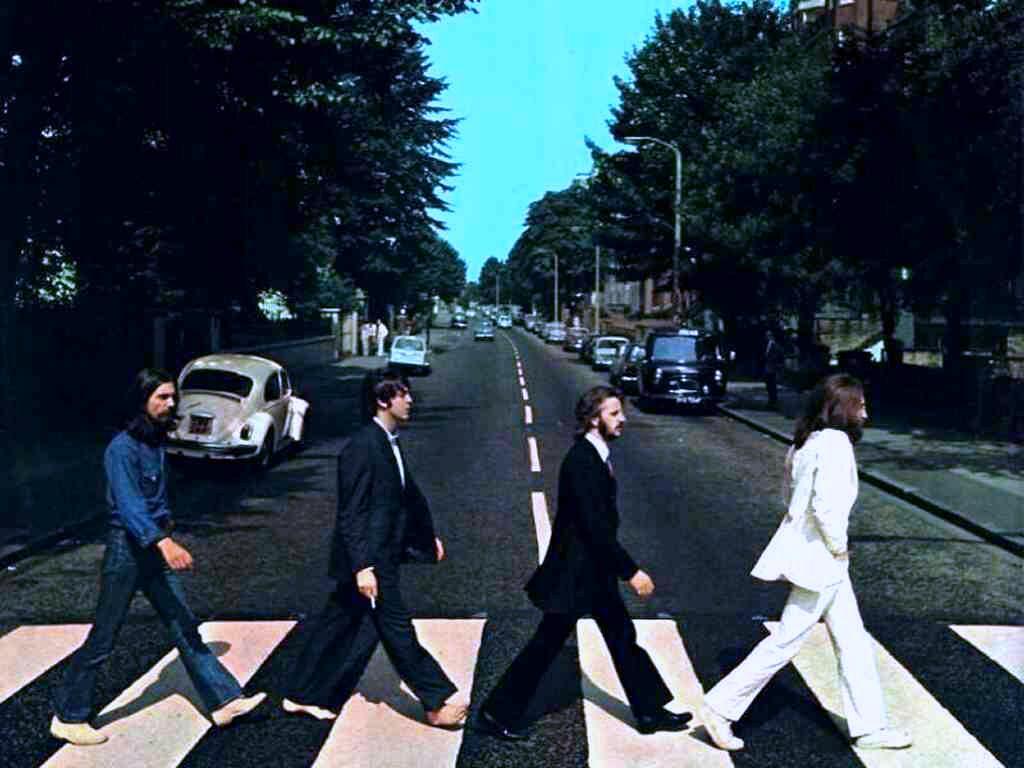Please provide a concise description of this image. This picture might be taken on the wide road. In this image, in the middle, we can see four men are walking on the road. On the right side, we can see some trees, buildings, we can also see a person standing on the footpath on the right side. On the left side, we can see some trees, wall. In the background, we can see some cars, street lights. On the top, we can see a sky, at the bottom there is a road and a footpath. 